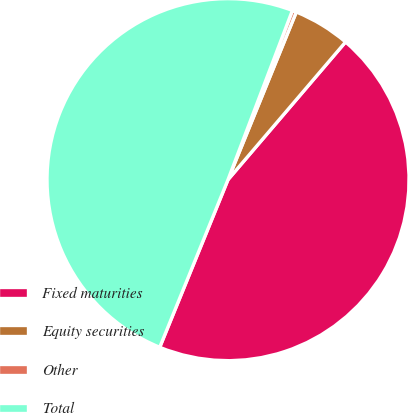<chart> <loc_0><loc_0><loc_500><loc_500><pie_chart><fcel>Fixed maturities<fcel>Equity securities<fcel>Other<fcel>Total<nl><fcel>44.91%<fcel>5.09%<fcel>0.37%<fcel>49.63%<nl></chart> 